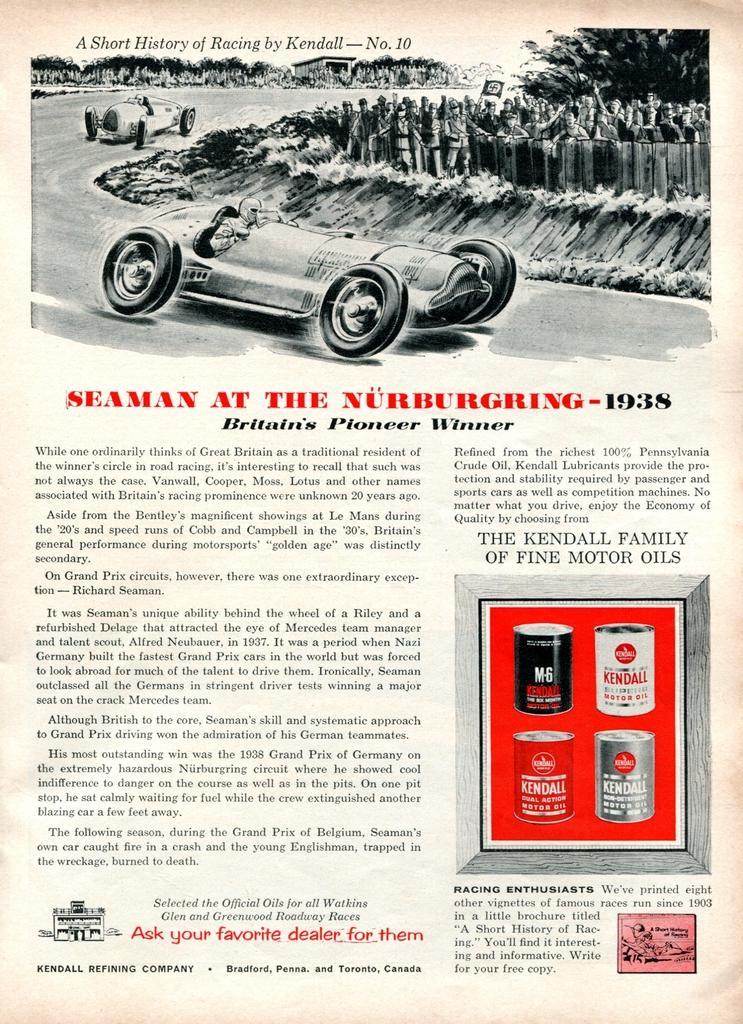Please provide a concise description of this image. In this picture we can see poster, in this poster we can see vehicles, people, trees and some information. 